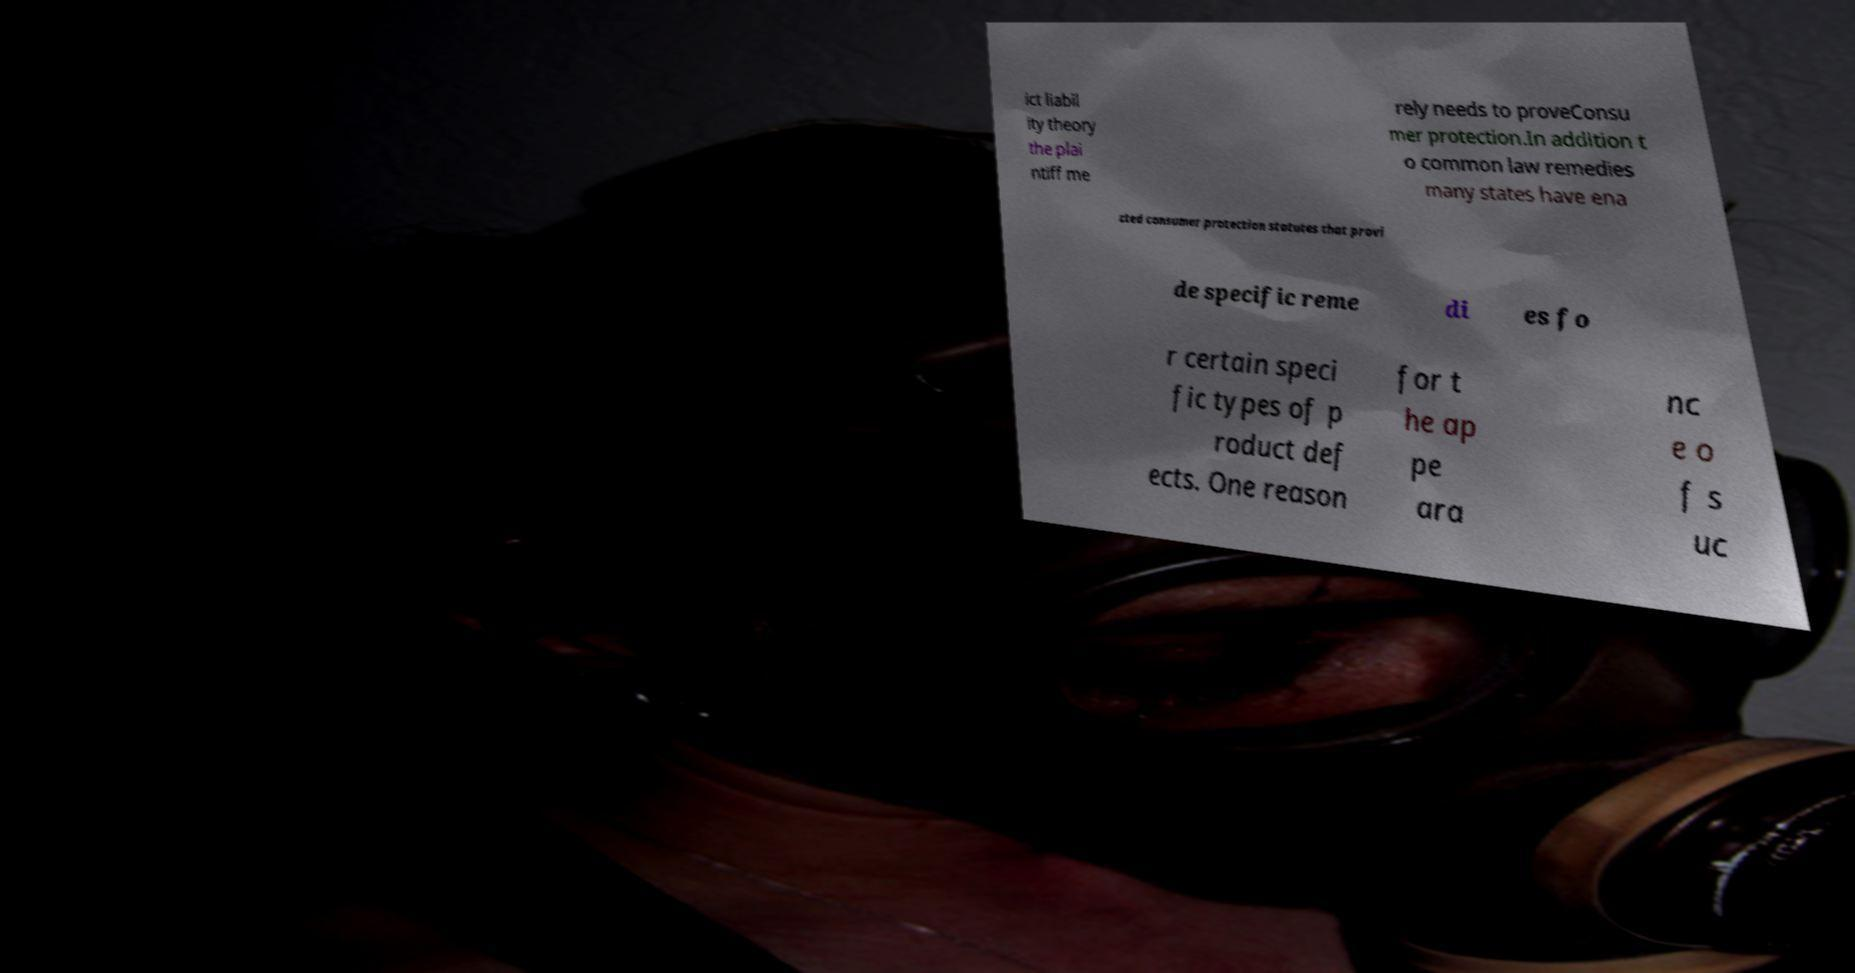What messages or text are displayed in this image? I need them in a readable, typed format. ict liabil ity theory the plai ntiff me rely needs to proveConsu mer protection.In addition t o common law remedies many states have ena cted consumer protection statutes that provi de specific reme di es fo r certain speci fic types of p roduct def ects. One reason for t he ap pe ara nc e o f s uc 